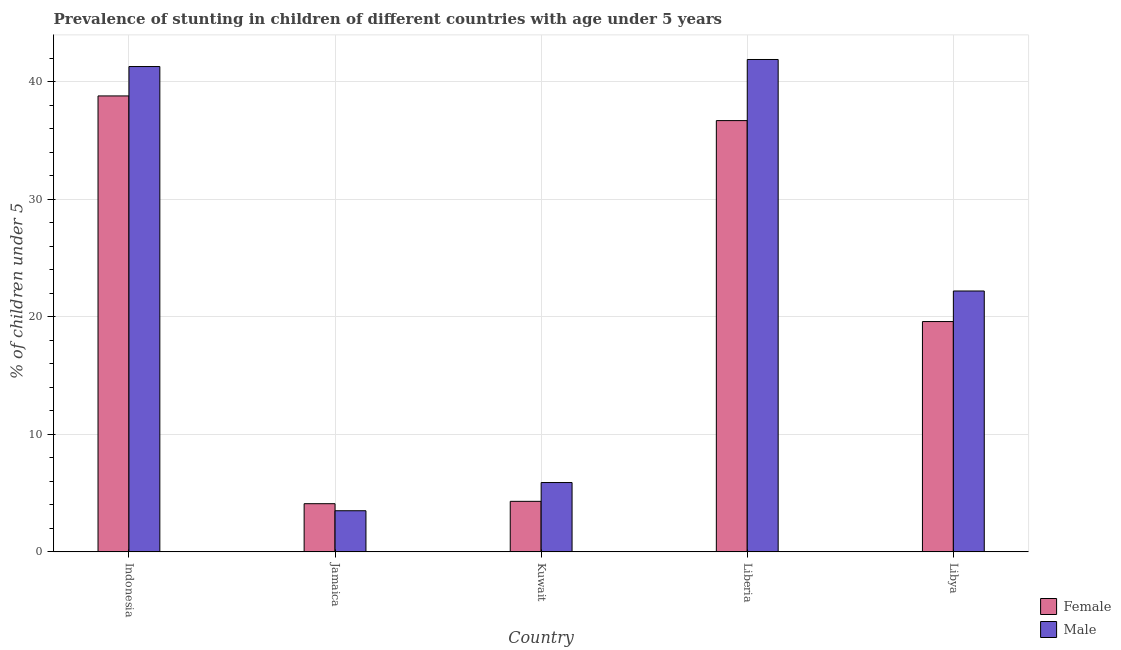How many different coloured bars are there?
Make the answer very short. 2. How many groups of bars are there?
Your answer should be compact. 5. How many bars are there on the 4th tick from the left?
Provide a succinct answer. 2. How many bars are there on the 1st tick from the right?
Offer a very short reply. 2. In how many cases, is the number of bars for a given country not equal to the number of legend labels?
Offer a very short reply. 0. What is the percentage of stunted female children in Libya?
Your response must be concise. 19.6. Across all countries, what is the maximum percentage of stunted male children?
Offer a very short reply. 41.9. Across all countries, what is the minimum percentage of stunted female children?
Keep it short and to the point. 4.1. In which country was the percentage of stunted male children maximum?
Provide a succinct answer. Liberia. In which country was the percentage of stunted female children minimum?
Provide a succinct answer. Jamaica. What is the total percentage of stunted male children in the graph?
Keep it short and to the point. 114.8. What is the difference between the percentage of stunted male children in Jamaica and that in Kuwait?
Offer a very short reply. -2.4. What is the difference between the percentage of stunted female children in Liberia and the percentage of stunted male children in Jamaica?
Your answer should be very brief. 33.2. What is the average percentage of stunted male children per country?
Keep it short and to the point. 22.96. In how many countries, is the percentage of stunted male children greater than 32 %?
Ensure brevity in your answer.  2. What is the ratio of the percentage of stunted male children in Kuwait to that in Libya?
Offer a very short reply. 0.27. Is the percentage of stunted male children in Indonesia less than that in Libya?
Your answer should be very brief. No. What is the difference between the highest and the second highest percentage of stunted female children?
Offer a very short reply. 2.1. What is the difference between the highest and the lowest percentage of stunted female children?
Your answer should be very brief. 34.7. In how many countries, is the percentage of stunted female children greater than the average percentage of stunted female children taken over all countries?
Ensure brevity in your answer.  2. Is the sum of the percentage of stunted female children in Jamaica and Kuwait greater than the maximum percentage of stunted male children across all countries?
Offer a very short reply. No. How many bars are there?
Keep it short and to the point. 10. Are all the bars in the graph horizontal?
Your response must be concise. No. Are the values on the major ticks of Y-axis written in scientific E-notation?
Offer a very short reply. No. Does the graph contain grids?
Give a very brief answer. Yes. What is the title of the graph?
Make the answer very short. Prevalence of stunting in children of different countries with age under 5 years. What is the label or title of the X-axis?
Your response must be concise. Country. What is the label or title of the Y-axis?
Keep it short and to the point.  % of children under 5. What is the  % of children under 5 of Female in Indonesia?
Provide a short and direct response. 38.8. What is the  % of children under 5 of Male in Indonesia?
Make the answer very short. 41.3. What is the  % of children under 5 of Female in Jamaica?
Your answer should be very brief. 4.1. What is the  % of children under 5 of Female in Kuwait?
Ensure brevity in your answer.  4.3. What is the  % of children under 5 in Male in Kuwait?
Ensure brevity in your answer.  5.9. What is the  % of children under 5 of Female in Liberia?
Provide a short and direct response. 36.7. What is the  % of children under 5 of Male in Liberia?
Give a very brief answer. 41.9. What is the  % of children under 5 in Female in Libya?
Your answer should be very brief. 19.6. What is the  % of children under 5 of Male in Libya?
Provide a short and direct response. 22.2. Across all countries, what is the maximum  % of children under 5 in Female?
Offer a very short reply. 38.8. Across all countries, what is the maximum  % of children under 5 in Male?
Ensure brevity in your answer.  41.9. Across all countries, what is the minimum  % of children under 5 in Female?
Keep it short and to the point. 4.1. What is the total  % of children under 5 in Female in the graph?
Ensure brevity in your answer.  103.5. What is the total  % of children under 5 of Male in the graph?
Your response must be concise. 114.8. What is the difference between the  % of children under 5 in Female in Indonesia and that in Jamaica?
Your answer should be compact. 34.7. What is the difference between the  % of children under 5 in Male in Indonesia and that in Jamaica?
Make the answer very short. 37.8. What is the difference between the  % of children under 5 in Female in Indonesia and that in Kuwait?
Provide a succinct answer. 34.5. What is the difference between the  % of children under 5 of Male in Indonesia and that in Kuwait?
Your answer should be compact. 35.4. What is the difference between the  % of children under 5 of Female in Indonesia and that in Libya?
Provide a succinct answer. 19.2. What is the difference between the  % of children under 5 in Male in Indonesia and that in Libya?
Ensure brevity in your answer.  19.1. What is the difference between the  % of children under 5 of Female in Jamaica and that in Kuwait?
Your answer should be compact. -0.2. What is the difference between the  % of children under 5 of Male in Jamaica and that in Kuwait?
Give a very brief answer. -2.4. What is the difference between the  % of children under 5 in Female in Jamaica and that in Liberia?
Your response must be concise. -32.6. What is the difference between the  % of children under 5 of Male in Jamaica and that in Liberia?
Offer a terse response. -38.4. What is the difference between the  % of children under 5 of Female in Jamaica and that in Libya?
Keep it short and to the point. -15.5. What is the difference between the  % of children under 5 in Male in Jamaica and that in Libya?
Make the answer very short. -18.7. What is the difference between the  % of children under 5 in Female in Kuwait and that in Liberia?
Provide a short and direct response. -32.4. What is the difference between the  % of children under 5 of Male in Kuwait and that in Liberia?
Your answer should be very brief. -36. What is the difference between the  % of children under 5 in Female in Kuwait and that in Libya?
Provide a succinct answer. -15.3. What is the difference between the  % of children under 5 of Male in Kuwait and that in Libya?
Your answer should be compact. -16.3. What is the difference between the  % of children under 5 of Female in Liberia and that in Libya?
Provide a short and direct response. 17.1. What is the difference between the  % of children under 5 of Female in Indonesia and the  % of children under 5 of Male in Jamaica?
Make the answer very short. 35.3. What is the difference between the  % of children under 5 in Female in Indonesia and the  % of children under 5 in Male in Kuwait?
Keep it short and to the point. 32.9. What is the difference between the  % of children under 5 in Female in Indonesia and the  % of children under 5 in Male in Libya?
Keep it short and to the point. 16.6. What is the difference between the  % of children under 5 of Female in Jamaica and the  % of children under 5 of Male in Kuwait?
Offer a terse response. -1.8. What is the difference between the  % of children under 5 of Female in Jamaica and the  % of children under 5 of Male in Liberia?
Provide a short and direct response. -37.8. What is the difference between the  % of children under 5 of Female in Jamaica and the  % of children under 5 of Male in Libya?
Offer a terse response. -18.1. What is the difference between the  % of children under 5 in Female in Kuwait and the  % of children under 5 in Male in Liberia?
Keep it short and to the point. -37.6. What is the difference between the  % of children under 5 in Female in Kuwait and the  % of children under 5 in Male in Libya?
Keep it short and to the point. -17.9. What is the difference between the  % of children under 5 in Female in Liberia and the  % of children under 5 in Male in Libya?
Give a very brief answer. 14.5. What is the average  % of children under 5 in Female per country?
Give a very brief answer. 20.7. What is the average  % of children under 5 in Male per country?
Ensure brevity in your answer.  22.96. What is the difference between the  % of children under 5 of Female and  % of children under 5 of Male in Indonesia?
Your response must be concise. -2.5. What is the difference between the  % of children under 5 of Female and  % of children under 5 of Male in Jamaica?
Offer a terse response. 0.6. What is the difference between the  % of children under 5 in Female and  % of children under 5 in Male in Kuwait?
Make the answer very short. -1.6. What is the difference between the  % of children under 5 in Female and  % of children under 5 in Male in Libya?
Make the answer very short. -2.6. What is the ratio of the  % of children under 5 of Female in Indonesia to that in Jamaica?
Your answer should be compact. 9.46. What is the ratio of the  % of children under 5 in Male in Indonesia to that in Jamaica?
Offer a terse response. 11.8. What is the ratio of the  % of children under 5 of Female in Indonesia to that in Kuwait?
Ensure brevity in your answer.  9.02. What is the ratio of the  % of children under 5 of Male in Indonesia to that in Kuwait?
Your answer should be compact. 7. What is the ratio of the  % of children under 5 in Female in Indonesia to that in Liberia?
Give a very brief answer. 1.06. What is the ratio of the  % of children under 5 of Male in Indonesia to that in Liberia?
Provide a short and direct response. 0.99. What is the ratio of the  % of children under 5 in Female in Indonesia to that in Libya?
Your response must be concise. 1.98. What is the ratio of the  % of children under 5 in Male in Indonesia to that in Libya?
Offer a terse response. 1.86. What is the ratio of the  % of children under 5 of Female in Jamaica to that in Kuwait?
Offer a terse response. 0.95. What is the ratio of the  % of children under 5 in Male in Jamaica to that in Kuwait?
Offer a terse response. 0.59. What is the ratio of the  % of children under 5 in Female in Jamaica to that in Liberia?
Make the answer very short. 0.11. What is the ratio of the  % of children under 5 in Male in Jamaica to that in Liberia?
Keep it short and to the point. 0.08. What is the ratio of the  % of children under 5 of Female in Jamaica to that in Libya?
Your answer should be compact. 0.21. What is the ratio of the  % of children under 5 in Male in Jamaica to that in Libya?
Keep it short and to the point. 0.16. What is the ratio of the  % of children under 5 of Female in Kuwait to that in Liberia?
Provide a short and direct response. 0.12. What is the ratio of the  % of children under 5 of Male in Kuwait to that in Liberia?
Ensure brevity in your answer.  0.14. What is the ratio of the  % of children under 5 of Female in Kuwait to that in Libya?
Offer a terse response. 0.22. What is the ratio of the  % of children under 5 of Male in Kuwait to that in Libya?
Your response must be concise. 0.27. What is the ratio of the  % of children under 5 of Female in Liberia to that in Libya?
Give a very brief answer. 1.87. What is the ratio of the  % of children under 5 in Male in Liberia to that in Libya?
Your answer should be compact. 1.89. What is the difference between the highest and the second highest  % of children under 5 of Female?
Give a very brief answer. 2.1. What is the difference between the highest and the second highest  % of children under 5 of Male?
Offer a very short reply. 0.6. What is the difference between the highest and the lowest  % of children under 5 of Female?
Your response must be concise. 34.7. What is the difference between the highest and the lowest  % of children under 5 of Male?
Provide a short and direct response. 38.4. 